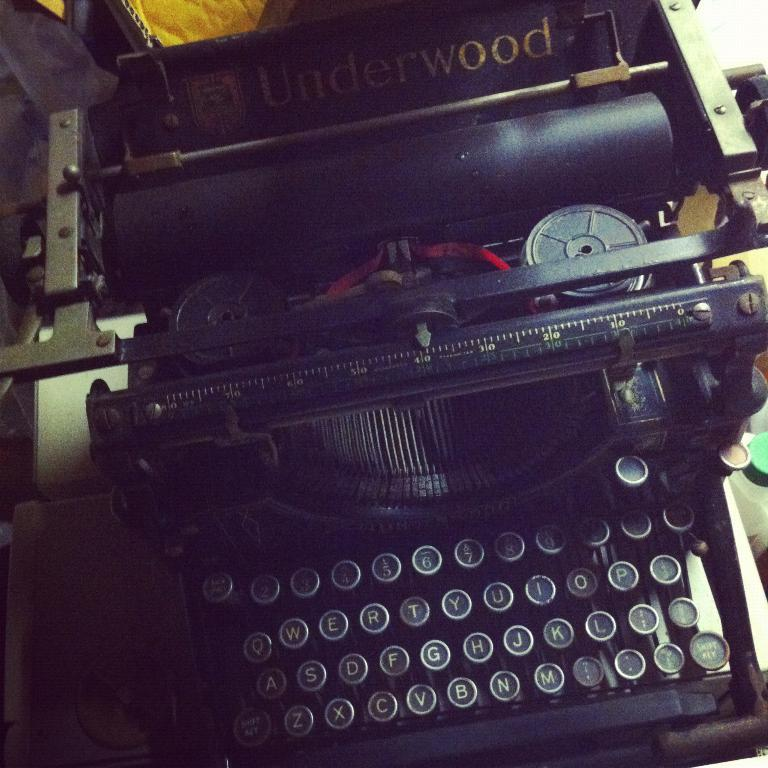<image>
Present a compact description of the photo's key features. A typewriter with the word Underwood written on it. 